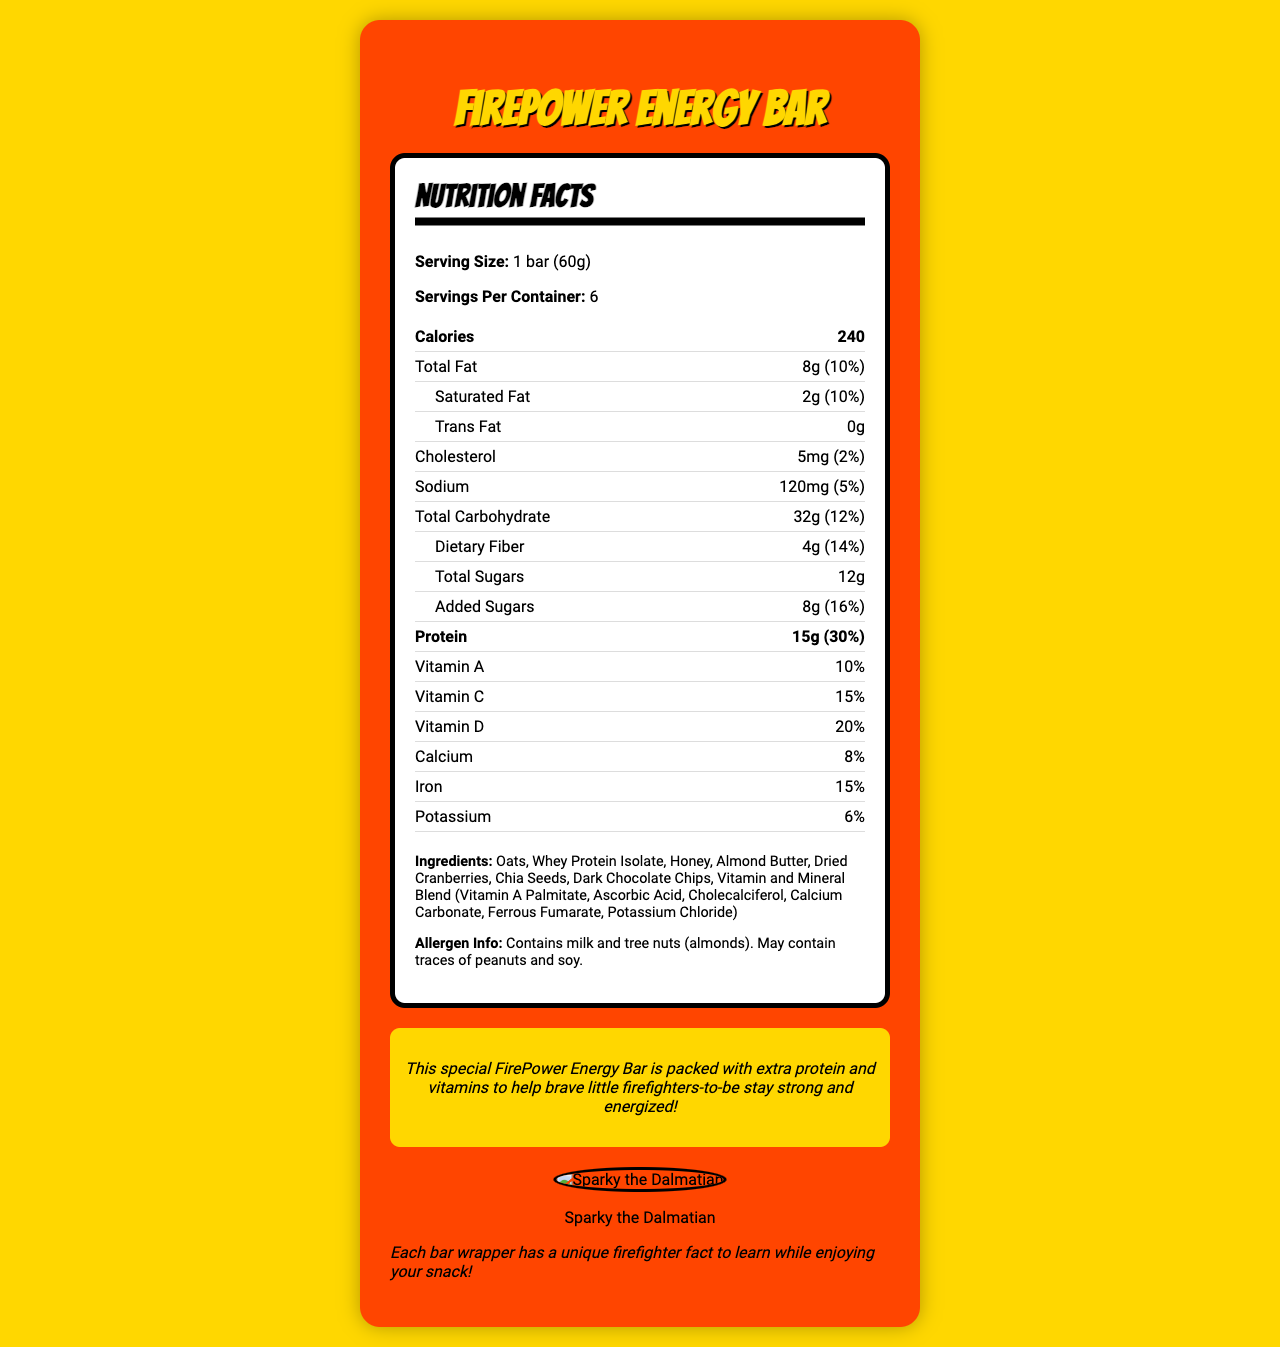what is the serving size of the FirePower Energy Bar? The serving size is clearly mentioned under the nutrition facts as "1 bar (60g)".
Answer: 1 bar (60g) how many servings are there per container? According to the document, each container has 6 servings.
Answer: 6 how many calories are in one bar? The nutrition facts state that each bar provides 240 calories.
Answer: 240 what is the total fat content in one bar? The total fat content is listed as 8g.
Answer: 8g what percentage of the daily value of protein does one bar provide? The document shows that one bar provides 30% of the daily value for protein.
Answer: 30% which ingredient is the primary source of protein in this bar? A. Almond Butter B. Oats C. Whey Protein Isolate D. Chia Seeds The ingredient list shows "Whey Protein Isolate" is a primary ingredient, indicating it is the main protein source.
Answer: C how much dietary fiber is in one bar? A. 2g B. 3g C. 4g The document states that each bar contains 4g of dietary fiber.
Answer: C are there any allergens in the FirePower Energy Bar? The allergen information clearly states that it contains milk and tree nuts (almonds), and may contain traces of peanuts and soy.
Answer: Yes is there any trans fat in the FirePower Energy Bar? The nutrition facts show that the trans fat content is 0g.
Answer: No describe the main idea of the FirePower Energy Bar nutrition label. The main idea of the label is to inform consumers about the nutritional benefits and content of the FirePower Energy Bar, highlighting its extra protein and vitamin content designed to support active and aspiring young firefighters.
Answer: The FirePower Energy Bar nutrition label provides comprehensive information on its nutritional content, ingredients, and allergen warnings. The bar contains 240 calories per serving, is rich in protein (15g), and contains various vitamins and minerals. It also has a fun fact section and a unique feature of including firefighter facts on each wrapper. how many grams of sugars are added to the FirePower Energy Bar? The nutrition facts state that there are 8g of added sugars.
Answer: 8g how much vitamin C is in one bar? The document indicates that one bar provides 15% of the daily value for vitamin C.
Answer: 15% what is the mascot of the FirePower Energy Bar? The document mentions that the mascot is Sparky the Dalmatian and includes an image.
Answer: Sparky the Dalmatian how much calcium is in one bar? According to the nutrition facts, one bar contains 8% of the daily value for calcium.
Answer: 8% does the FirePower Energy Bar provide information about firefighter facts? The document mentions that each bar wrapper has a unique firefighter fact to learn.
Answer: Yes how many bars are in one container? With each container having 6 servings and each serving being one bar, there are 6 bars in one container.
Answer: 6 bars what is the source of sweetness in the FirePower Energy Bar? The ingredient list includes honey as a source of sweetness.
Answer: Honey what is the daily value percentage of vitamin D provided by one bar? The nutrition facts state that one bar provides 20% of the daily value for vitamin D.
Answer: 20% is there potato in the ingredients list? The ingredients list does not mention potato.
Answer: No who produced the FirePower Energy Bar? The document does not provide information about the producer or manufacturer of the FirePower Energy Bar.
Answer: Not enough information 